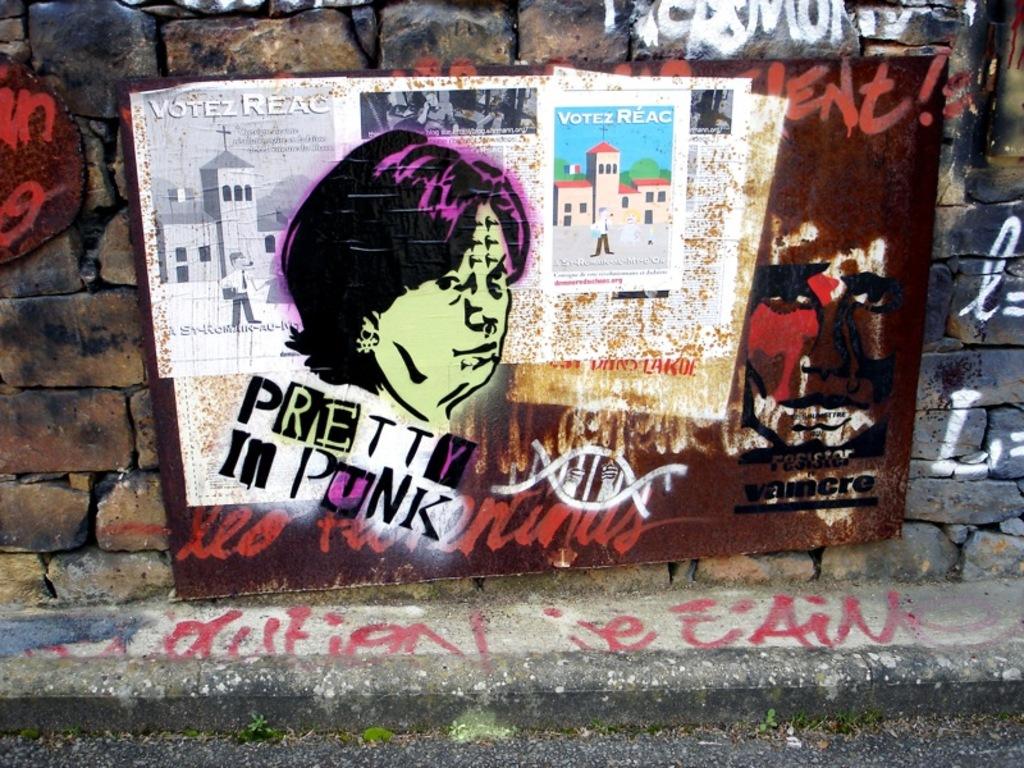What words are written under the head?
Your answer should be very brief. Pretty in punk. 